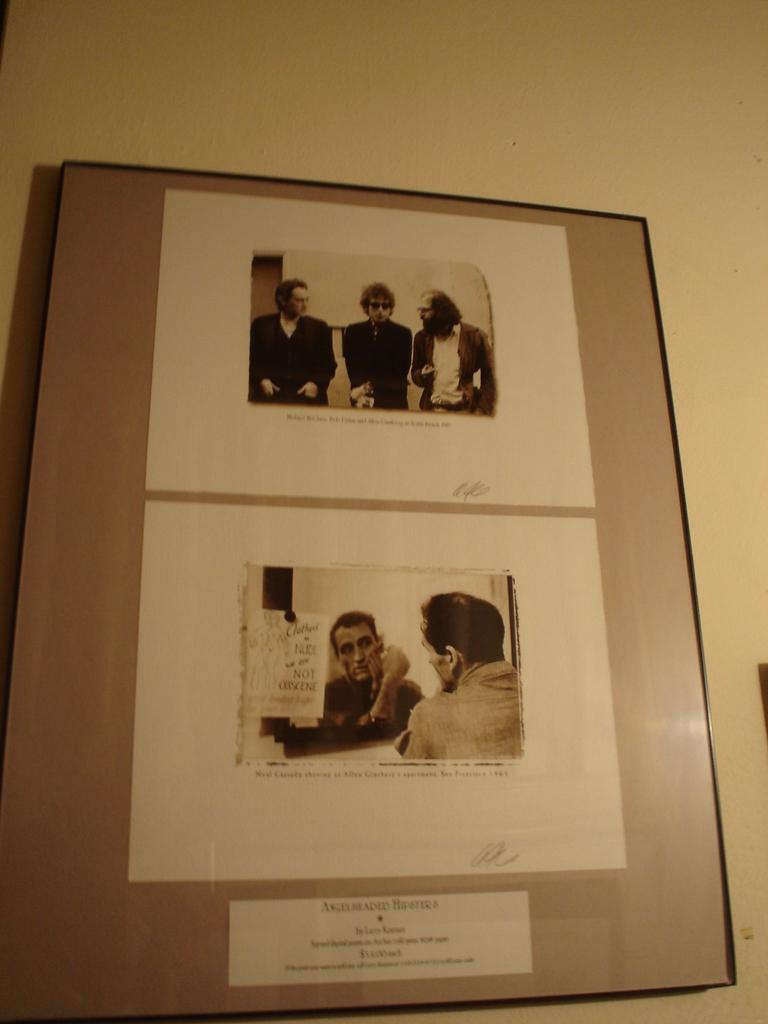In one or two sentences, can you explain what this image depicts? In this picture we can see a frame on the wall. There are few people in this frame. 